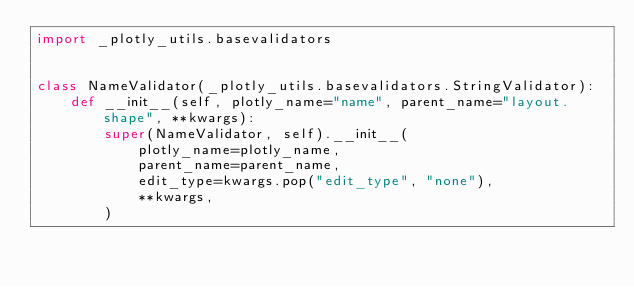<code> <loc_0><loc_0><loc_500><loc_500><_Python_>import _plotly_utils.basevalidators


class NameValidator(_plotly_utils.basevalidators.StringValidator):
    def __init__(self, plotly_name="name", parent_name="layout.shape", **kwargs):
        super(NameValidator, self).__init__(
            plotly_name=plotly_name,
            parent_name=parent_name,
            edit_type=kwargs.pop("edit_type", "none"),
            **kwargs,
        )
</code> 